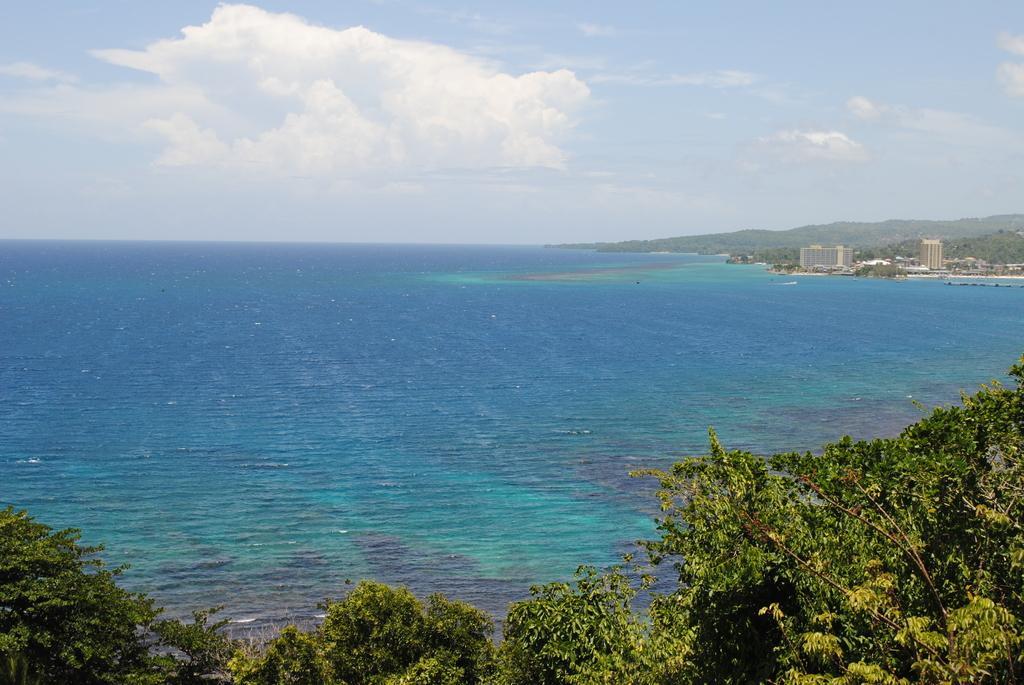Could you give a brief overview of what you see in this image? This image consists of water in the middle. There are trees at the bottom. There are buildings on the right side. There is sky at the top. 